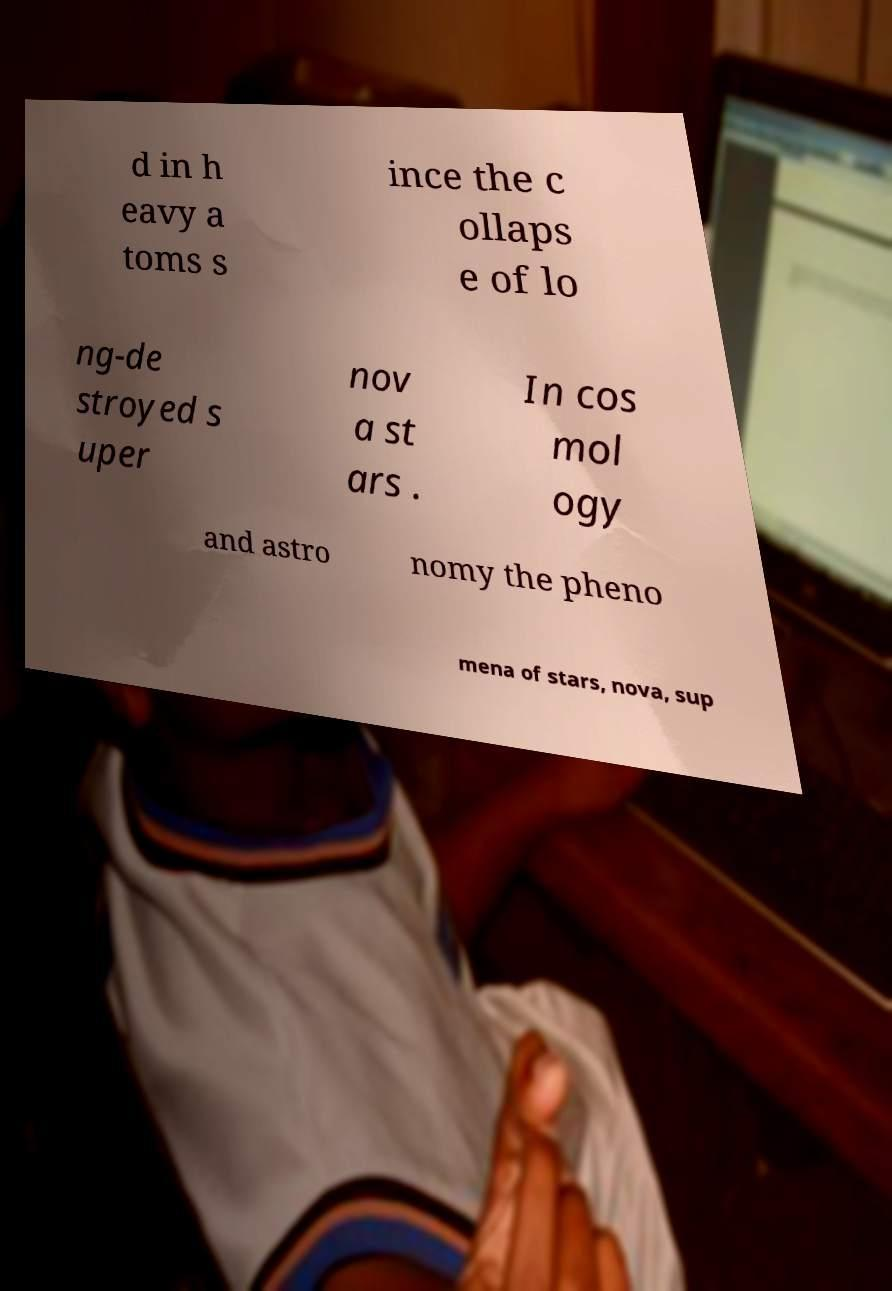I need the written content from this picture converted into text. Can you do that? d in h eavy a toms s ince the c ollaps e of lo ng-de stroyed s uper nov a st ars . In cos mol ogy and astro nomy the pheno mena of stars, nova, sup 